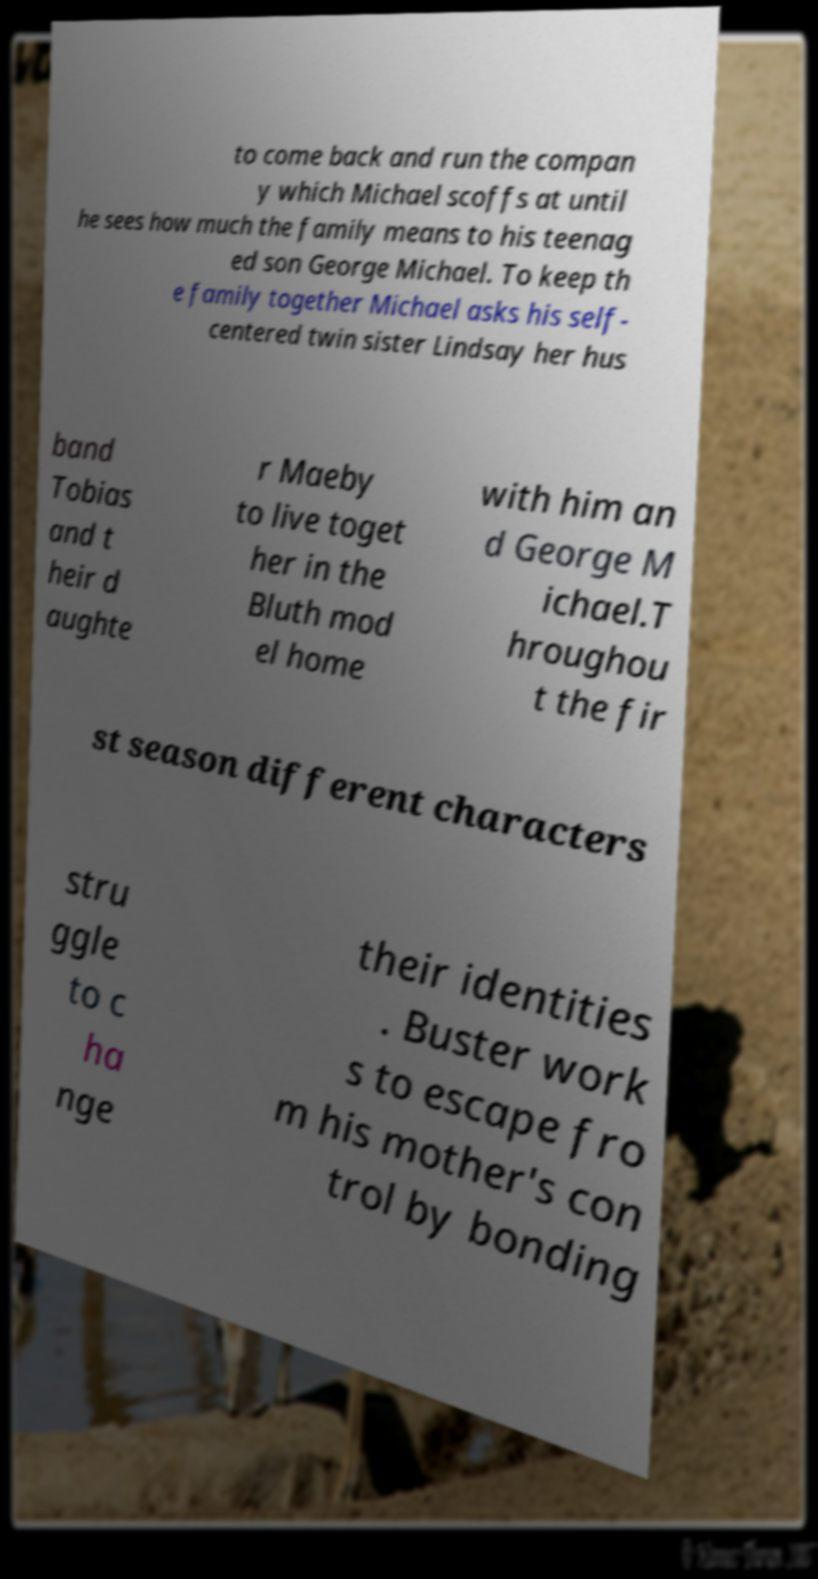What messages or text are displayed in this image? I need them in a readable, typed format. to come back and run the compan y which Michael scoffs at until he sees how much the family means to his teenag ed son George Michael. To keep th e family together Michael asks his self- centered twin sister Lindsay her hus band Tobias and t heir d aughte r Maeby to live toget her in the Bluth mod el home with him an d George M ichael.T hroughou t the fir st season different characters stru ggle to c ha nge their identities . Buster work s to escape fro m his mother's con trol by bonding 